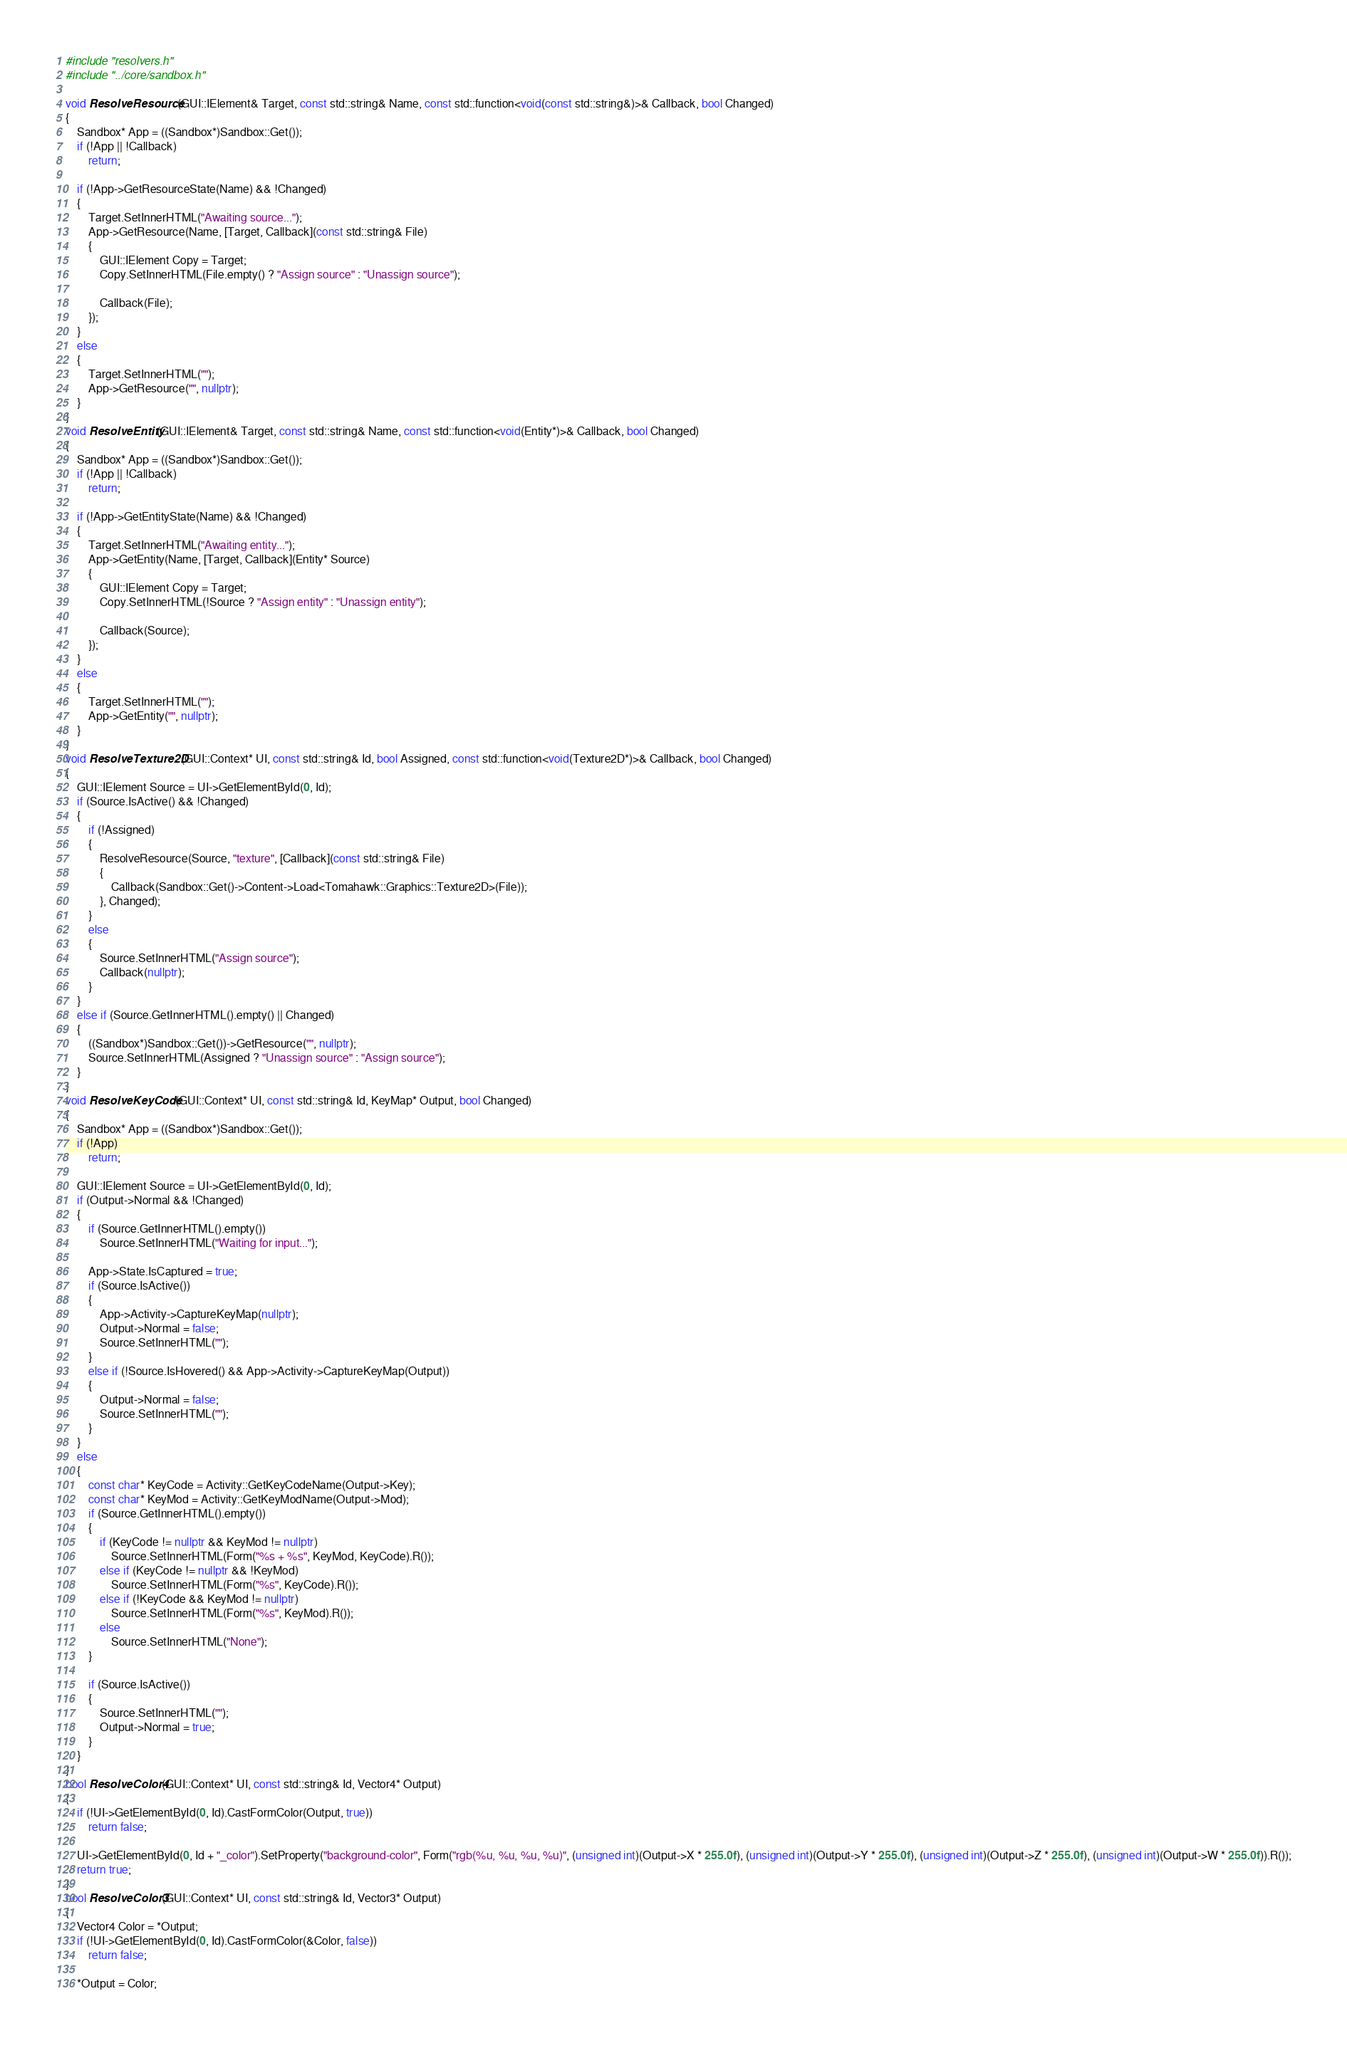Convert code to text. <code><loc_0><loc_0><loc_500><loc_500><_C++_>#include "resolvers.h"
#include "../core/sandbox.h"

void ResolveResource(GUI::IElement& Target, const std::string& Name, const std::function<void(const std::string&)>& Callback, bool Changed)
{
	Sandbox* App = ((Sandbox*)Sandbox::Get());
	if (!App || !Callback)
		return;

	if (!App->GetResourceState(Name) && !Changed)
	{
		Target.SetInnerHTML("Awaiting source...");
		App->GetResource(Name, [Target, Callback](const std::string& File)
		{
			GUI::IElement Copy = Target;
			Copy.SetInnerHTML(File.empty() ? "Assign source" : "Unassign source");

			Callback(File);
		});
	}
	else
	{
		Target.SetInnerHTML("");
		App->GetResource("", nullptr);
	}
}
void ResolveEntity(GUI::IElement& Target, const std::string& Name, const std::function<void(Entity*)>& Callback, bool Changed)
{
	Sandbox* App = ((Sandbox*)Sandbox::Get());
	if (!App || !Callback)
		return;

	if (!App->GetEntityState(Name) && !Changed)
	{
		Target.SetInnerHTML("Awaiting entity...");
		App->GetEntity(Name, [Target, Callback](Entity* Source)
		{
			GUI::IElement Copy = Target;
			Copy.SetInnerHTML(!Source ? "Assign entity" : "Unassign entity");

			Callback(Source);
		});
	}
	else
	{
		Target.SetInnerHTML("");
		App->GetEntity("", nullptr);
	}
}
void ResolveTexture2D(GUI::Context* UI, const std::string& Id, bool Assigned, const std::function<void(Texture2D*)>& Callback, bool Changed)
{
	GUI::IElement Source = UI->GetElementById(0, Id);
	if (Source.IsActive() && !Changed)
	{
		if (!Assigned)
		{
			ResolveResource(Source, "texture", [Callback](const std::string& File)
			{
				Callback(Sandbox::Get()->Content->Load<Tomahawk::Graphics::Texture2D>(File));
			}, Changed);
		}
		else
		{
			Source.SetInnerHTML("Assign source");
			Callback(nullptr);
		}
	}
	else if (Source.GetInnerHTML().empty() || Changed)
	{
		((Sandbox*)Sandbox::Get())->GetResource("", nullptr);
		Source.SetInnerHTML(Assigned ? "Unassign source" : "Assign source");
	}
}
void ResolveKeyCode(GUI::Context* UI, const std::string& Id, KeyMap* Output, bool Changed)
{
	Sandbox* App = ((Sandbox*)Sandbox::Get());
	if (!App)
		return;

	GUI::IElement Source = UI->GetElementById(0, Id);
	if (Output->Normal && !Changed)
	{
		if (Source.GetInnerHTML().empty())
			Source.SetInnerHTML("Waiting for input...");

		App->State.IsCaptured = true;
		if (Source.IsActive())
		{
			App->Activity->CaptureKeyMap(nullptr);
			Output->Normal = false;
			Source.SetInnerHTML("");
		}
		else if (!Source.IsHovered() && App->Activity->CaptureKeyMap(Output))
		{
			Output->Normal = false;
			Source.SetInnerHTML("");
		}
	}
	else
	{
		const char* KeyCode = Activity::GetKeyCodeName(Output->Key);
		const char* KeyMod = Activity::GetKeyModName(Output->Mod);
		if (Source.GetInnerHTML().empty())
		{
			if (KeyCode != nullptr && KeyMod != nullptr)
				Source.SetInnerHTML(Form("%s + %s", KeyMod, KeyCode).R());
			else if (KeyCode != nullptr && !KeyMod)
				Source.SetInnerHTML(Form("%s", KeyCode).R());
			else if (!KeyCode && KeyMod != nullptr)
				Source.SetInnerHTML(Form("%s", KeyMod).R());
			else
				Source.SetInnerHTML("None");
		}

		if (Source.IsActive())
		{
			Source.SetInnerHTML("");
			Output->Normal = true;
		}
	}
}
bool ResolveColor4(GUI::Context* UI, const std::string& Id, Vector4* Output)
{
	if (!UI->GetElementById(0, Id).CastFormColor(Output, true))
		return false;

	UI->GetElementById(0, Id + "_color").SetProperty("background-color", Form("rgb(%u, %u, %u, %u)", (unsigned int)(Output->X * 255.0f), (unsigned int)(Output->Y * 255.0f), (unsigned int)(Output->Z * 255.0f), (unsigned int)(Output->W * 255.0f)).R());
	return true;
}
bool ResolveColor3(GUI::Context* UI, const std::string& Id, Vector3* Output)
{
	Vector4 Color = *Output;
	if (!UI->GetElementById(0, Id).CastFormColor(&Color, false))
		return false;

	*Output = Color;</code> 